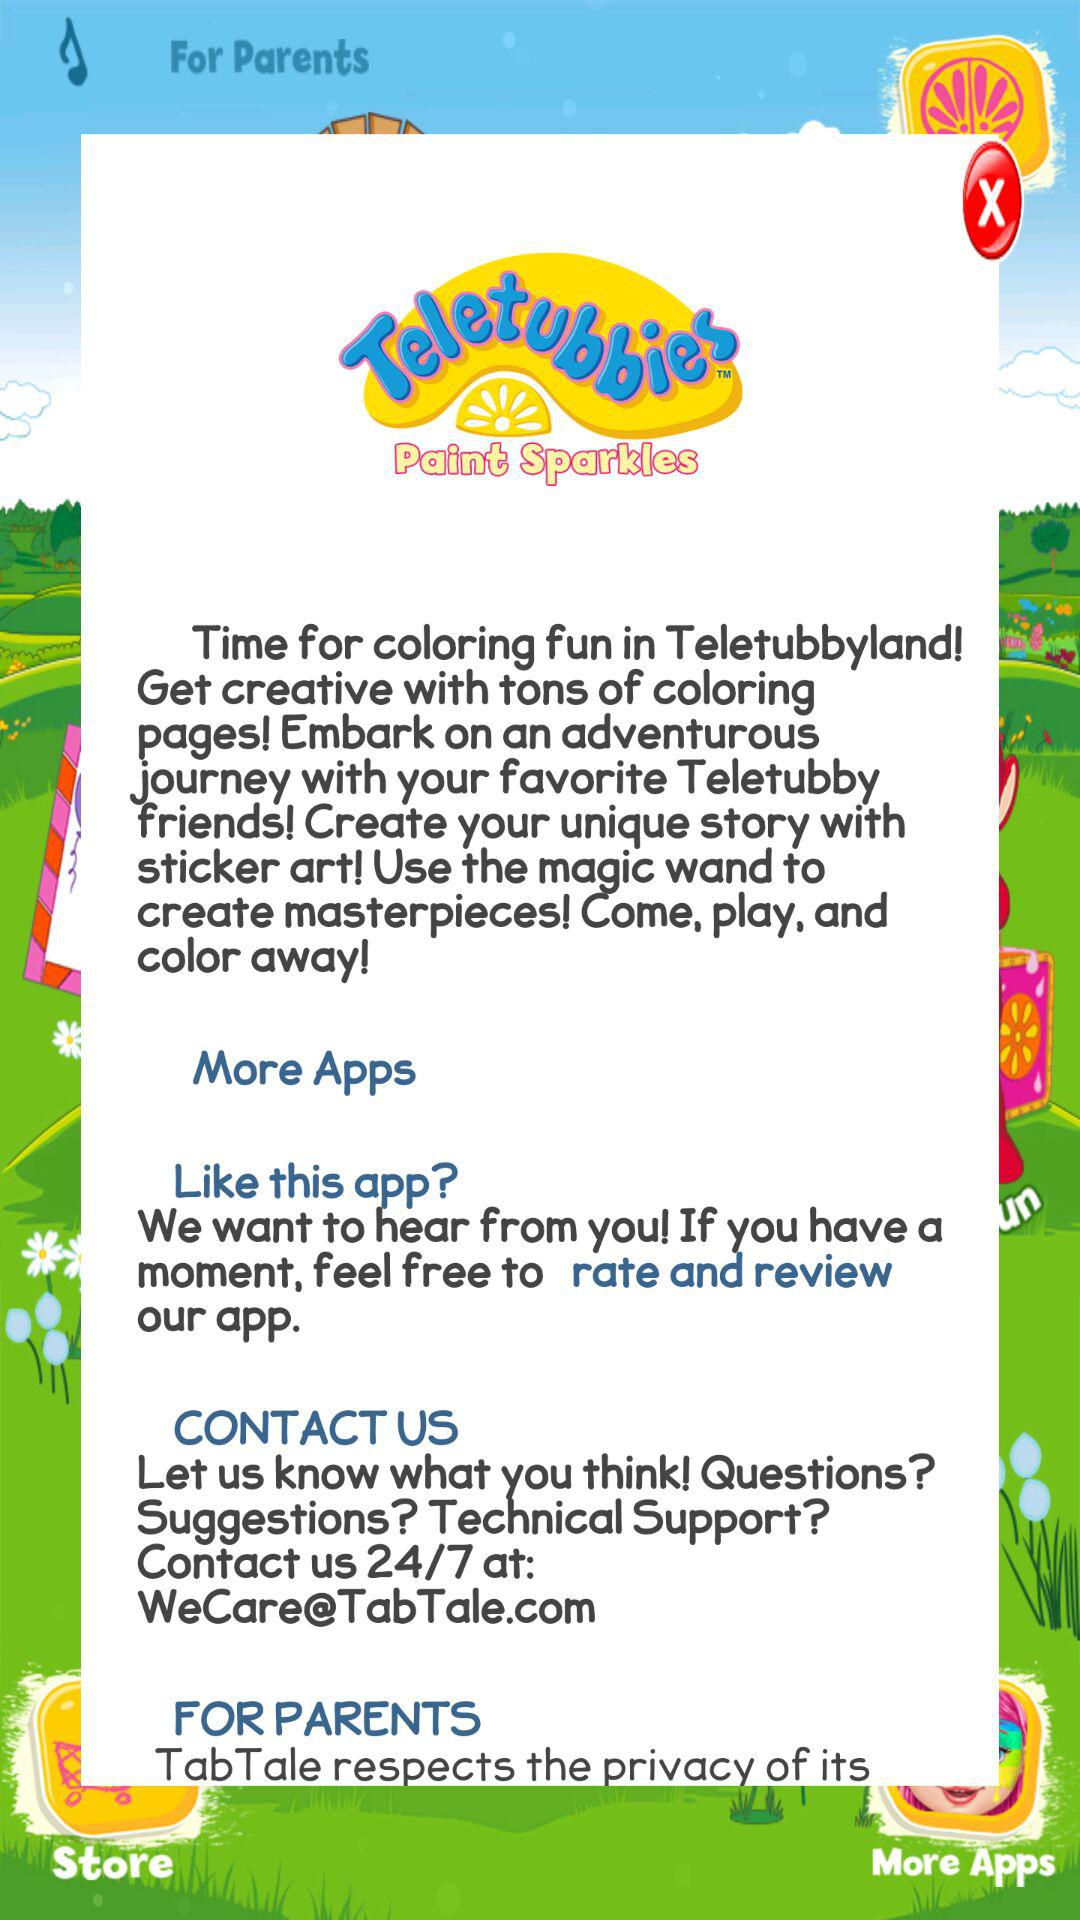What is the app title? The app title is "Teletubbies Paint Sparkles". 